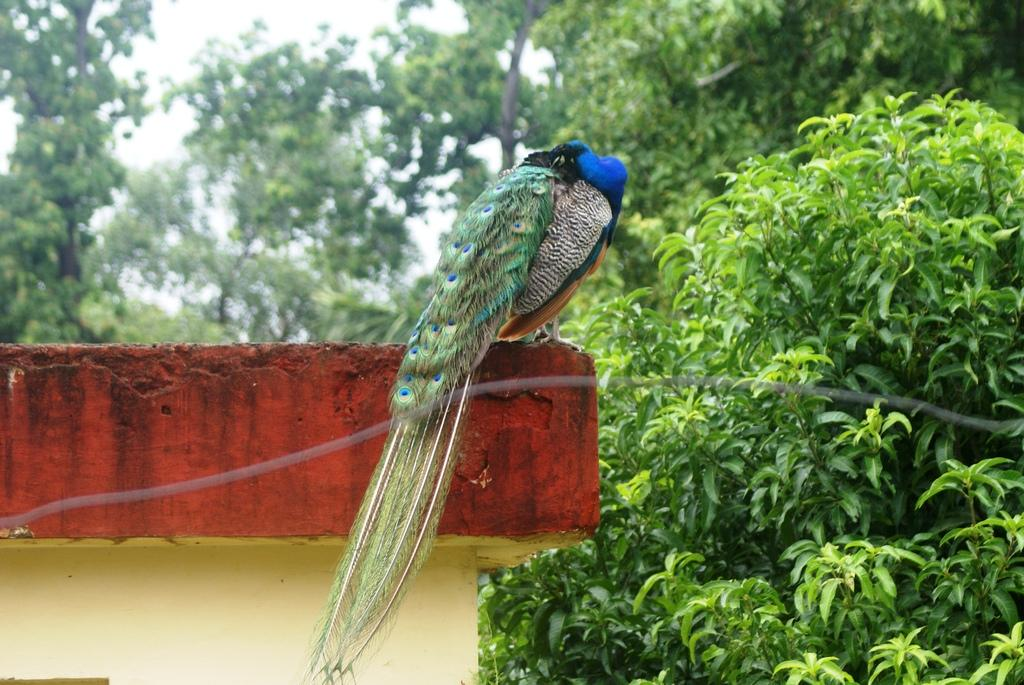What is on the wall in the image? There is a bird on the wall in the image. What colors can be seen on the bird? The bird has green and blue colors. What can be seen in the background of the image? There are trees and the sky visible in the background of the image. What color are the trees in the image? The trees are green in color. What color is the sky in the image? The sky is white in color. What effect does the bird have on the fictional world in the image? There is no fictional world present in the image, and the bird does not have any effect on a fictional world. 